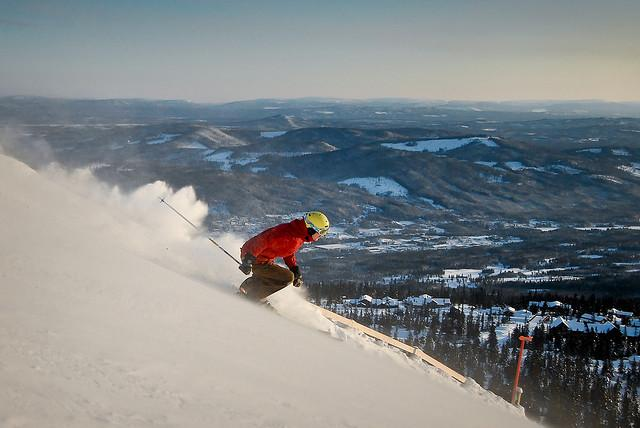What type of region is the man visiting? mountain 